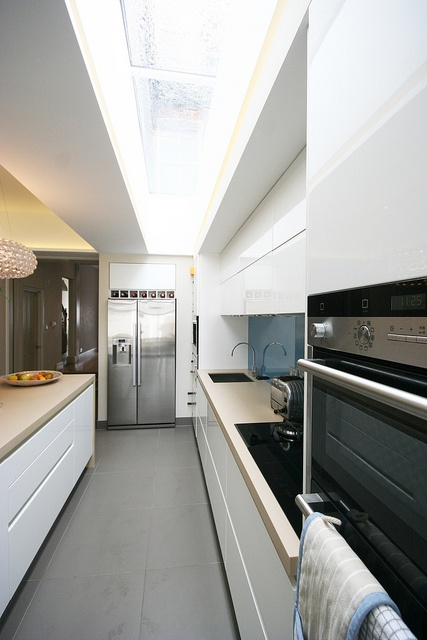Describe the objects in this image and their specific colors. I can see oven in gray, black, lightgray, and darkgray tones, refrigerator in gray, lightgray, darkgray, and black tones, clock in black and gray tones, sink in gray, black, and darkgray tones, and apple in gray, brown, tan, olive, and orange tones in this image. 